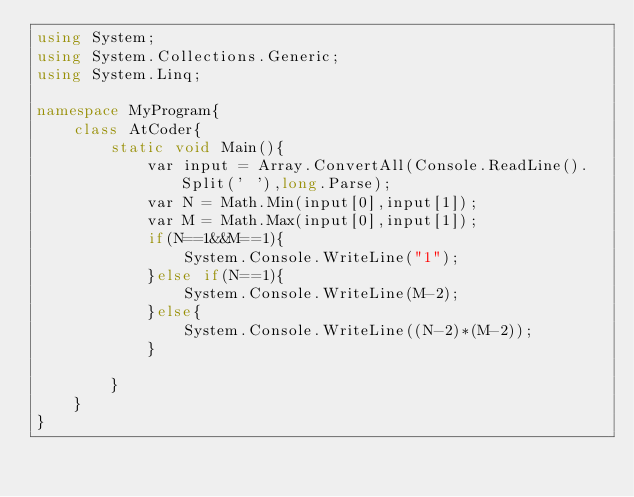<code> <loc_0><loc_0><loc_500><loc_500><_C#_>using System;
using System.Collections.Generic;
using System.Linq;

namespace MyProgram{
    class AtCoder{
        static void Main(){
            var input = Array.ConvertAll(Console.ReadLine().Split(' '),long.Parse);
            var N = Math.Min(input[0],input[1]);
            var M = Math.Max(input[0],input[1]);
            if(N==1&&M==1){
                System.Console.WriteLine("1");
            }else if(N==1){
                System.Console.WriteLine(M-2);
            }else{
                System.Console.WriteLine((N-2)*(M-2));
            }

        }
    } 
}
</code> 